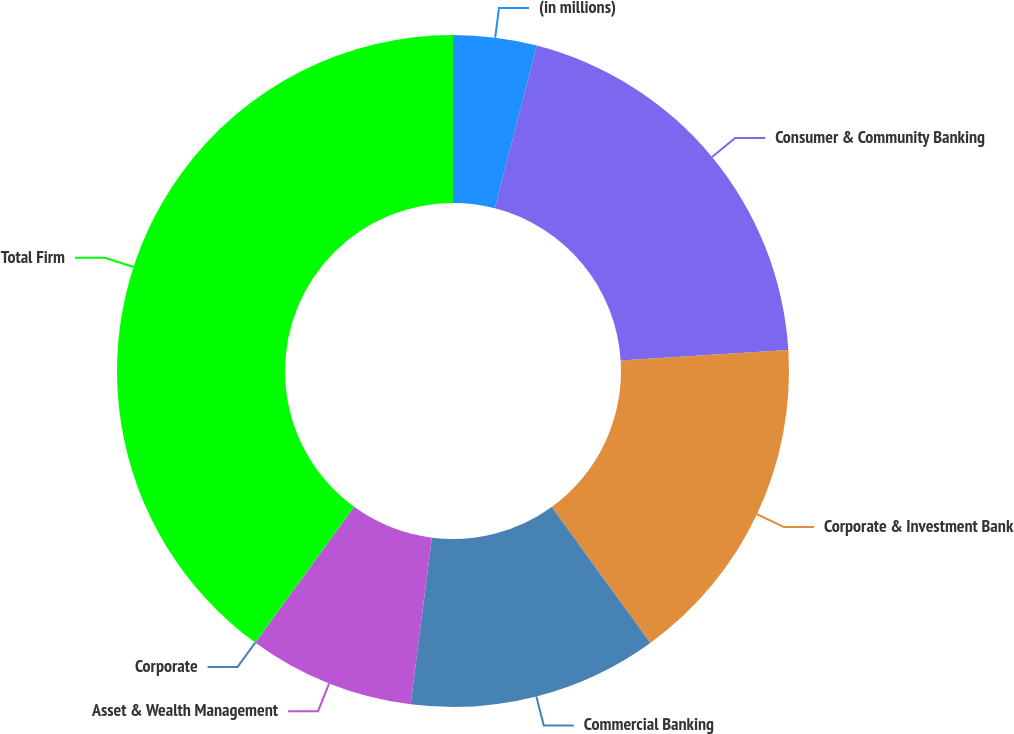Convert chart to OTSL. <chart><loc_0><loc_0><loc_500><loc_500><pie_chart><fcel>(in millions)<fcel>Consumer & Community Banking<fcel>Corporate & Investment Bank<fcel>Commercial Banking<fcel>Asset & Wealth Management<fcel>Corporate<fcel>Total Firm<nl><fcel>4.01%<fcel>20.0%<fcel>16.0%<fcel>12.0%<fcel>8.0%<fcel>0.01%<fcel>39.98%<nl></chart> 